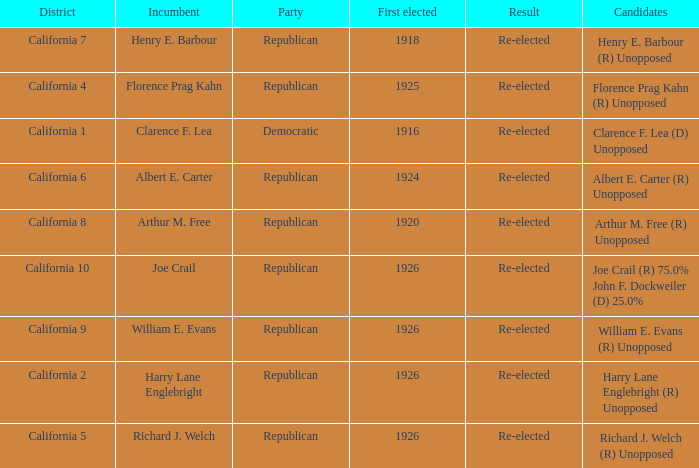What's the district with candidates being harry lane englebright (r) unopposed California 2. 